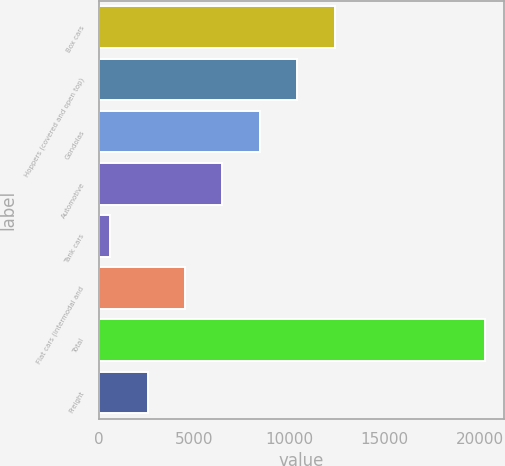Convert chart to OTSL. <chart><loc_0><loc_0><loc_500><loc_500><bar_chart><fcel>Box cars<fcel>Hoppers (covered and open top)<fcel>Gondolas<fcel>Automotive<fcel>Tank cars<fcel>Flat cars (intermodal and<fcel>Total<fcel>Freight<nl><fcel>12388.8<fcel>10424.5<fcel>8460.2<fcel>6495.9<fcel>603<fcel>4531.6<fcel>20246<fcel>2567.3<nl></chart> 